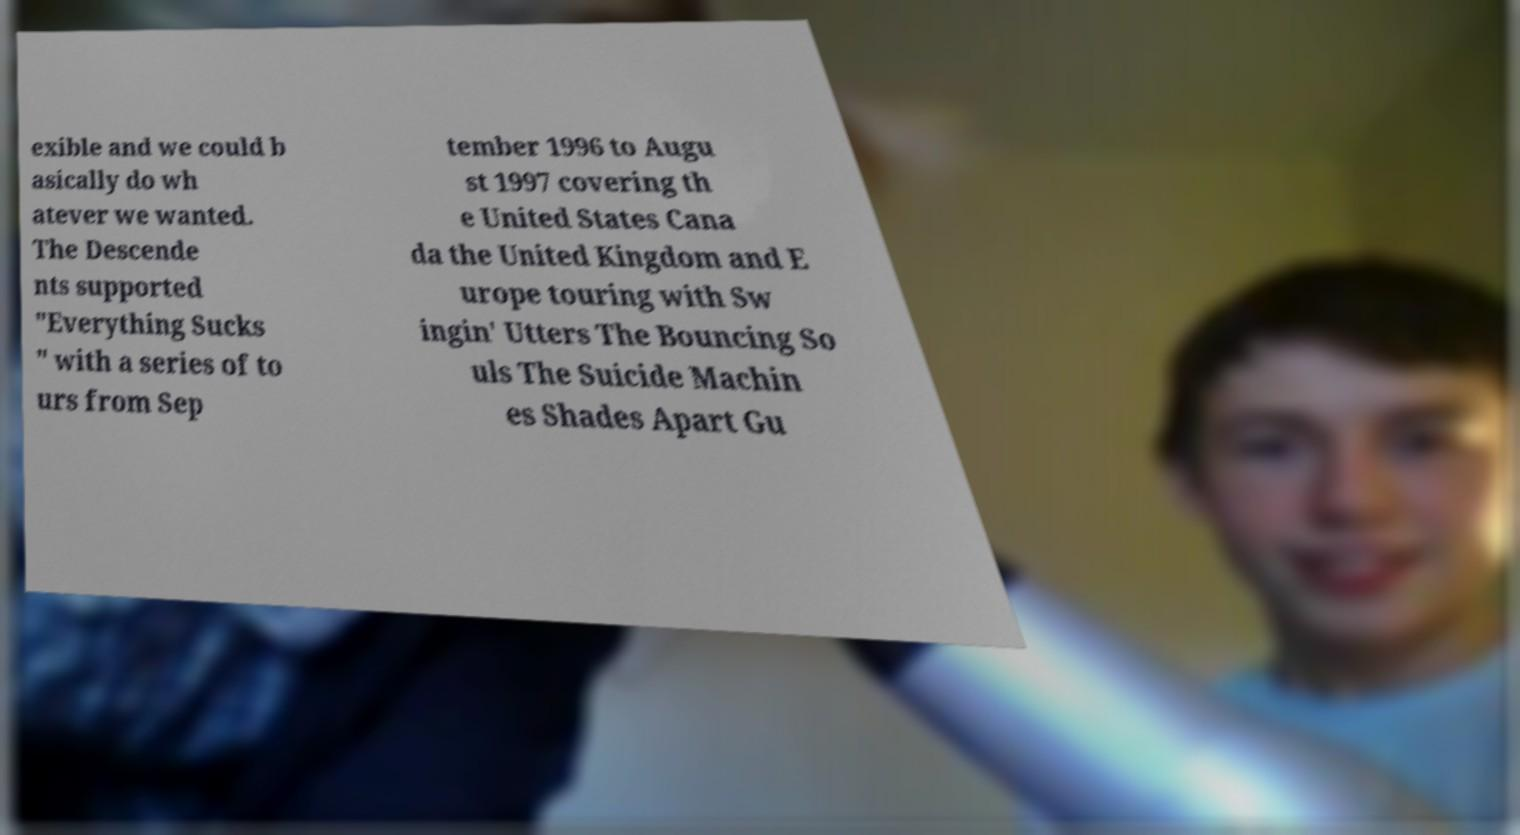Could you assist in decoding the text presented in this image and type it out clearly? exible and we could b asically do wh atever we wanted. The Descende nts supported "Everything Sucks " with a series of to urs from Sep tember 1996 to Augu st 1997 covering th e United States Cana da the United Kingdom and E urope touring with Sw ingin' Utters The Bouncing So uls The Suicide Machin es Shades Apart Gu 